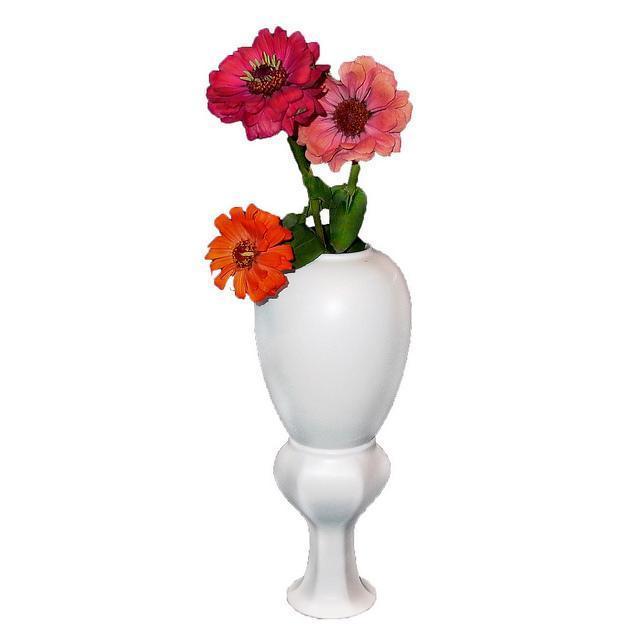How many flowers are in the vase?
Give a very brief answer. 3. 